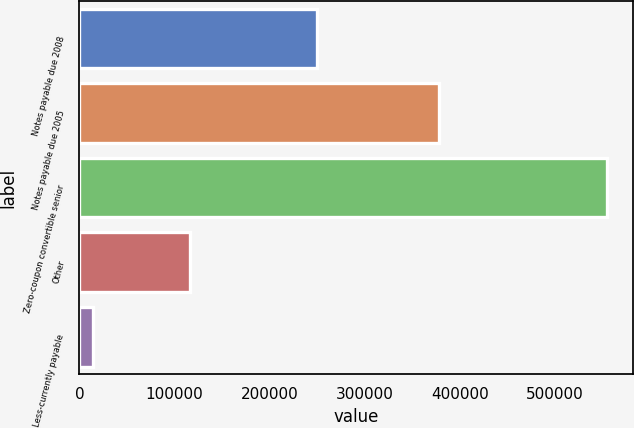Convert chart to OTSL. <chart><loc_0><loc_0><loc_500><loc_500><bar_chart><fcel>Notes payable due 2008<fcel>Notes payable due 2005<fcel>Zero-coupon convertible senior<fcel>Other<fcel>Less-currently payable<nl><fcel>250000<fcel>377850<fcel>554679<fcel>116354<fcel>14385<nl></chart> 